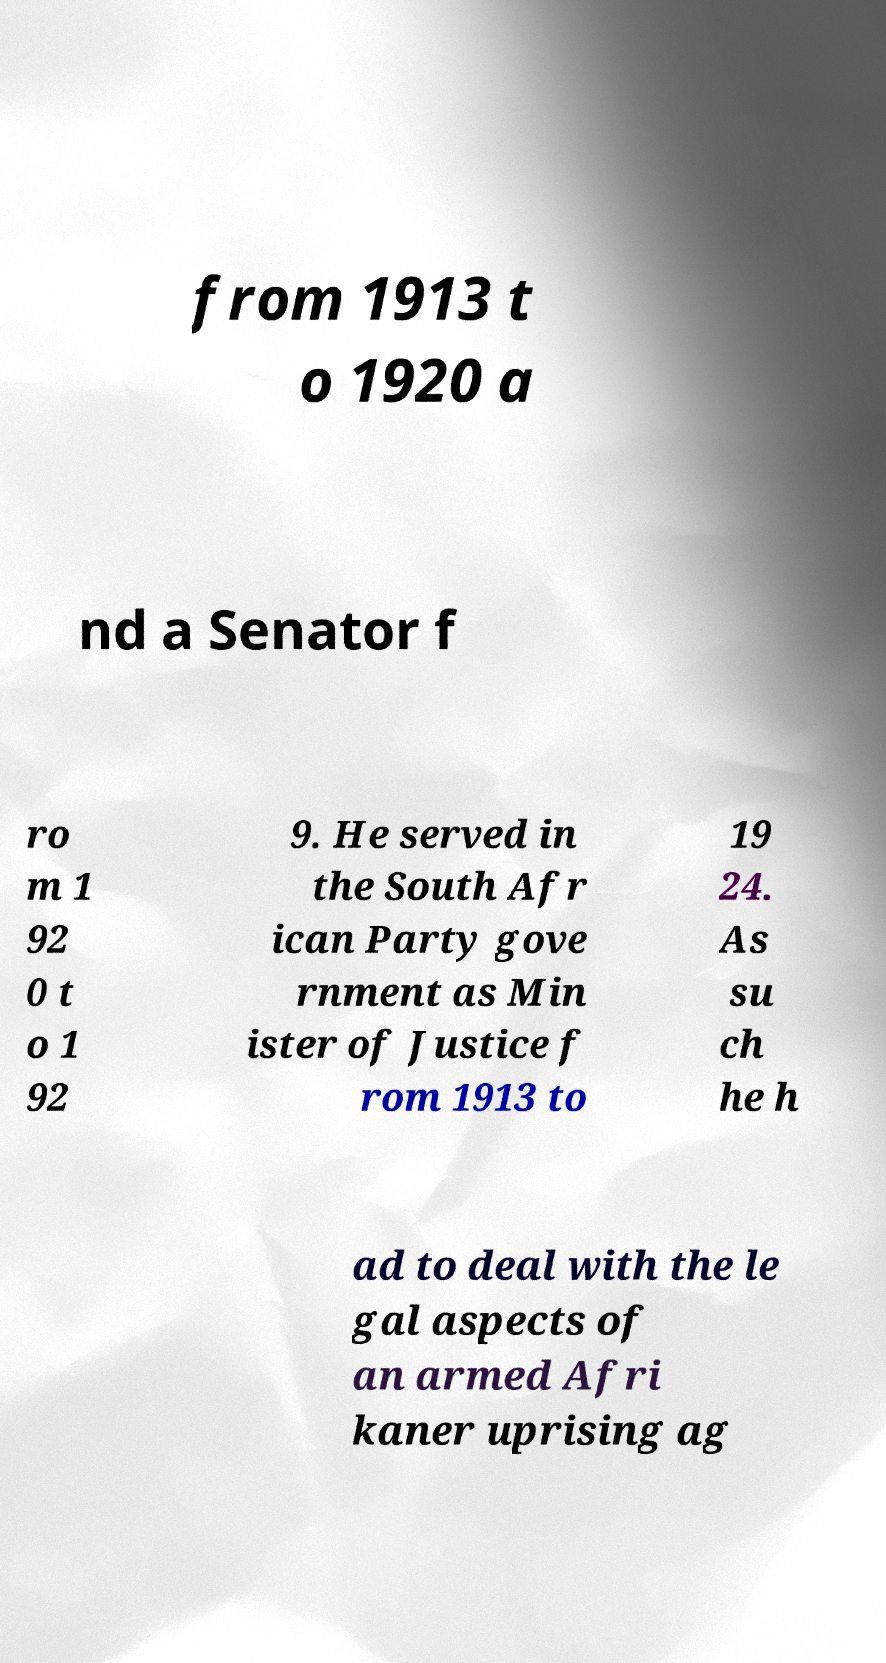There's text embedded in this image that I need extracted. Can you transcribe it verbatim? from 1913 t o 1920 a nd a Senator f ro m 1 92 0 t o 1 92 9. He served in the South Afr ican Party gove rnment as Min ister of Justice f rom 1913 to 19 24. As su ch he h ad to deal with the le gal aspects of an armed Afri kaner uprising ag 